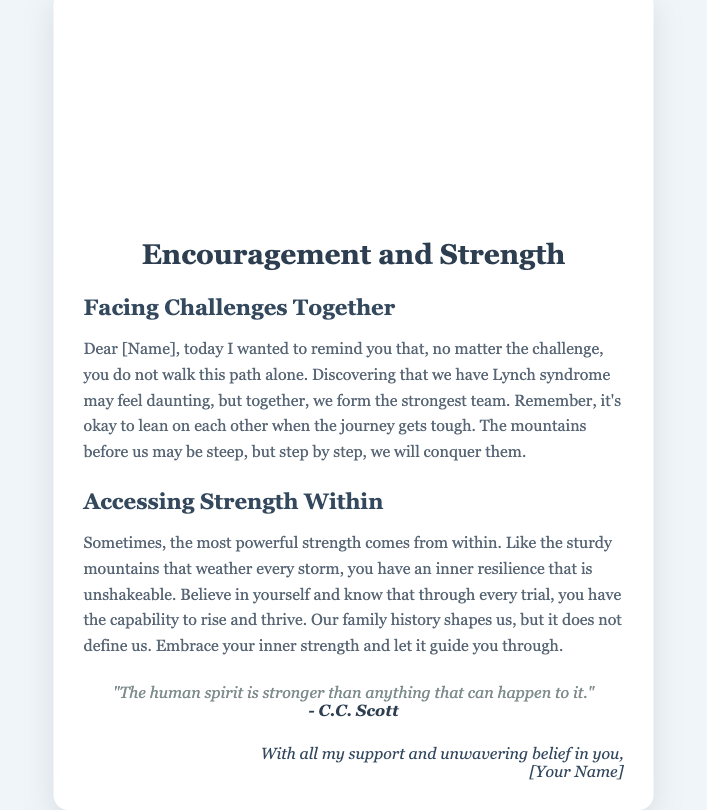What is the title of the card? The title is prominently displayed at the top of the card.
Answer: Encouragement and Strength Who is the quote attributed to? The author of the quote is mentioned at the end of the quote section.
Answer: C.C. Scott What is the main theme of the card? The card focuses on uplifting messages regarding overcoming challenges.
Answer: Encouragement and Strength What does the card encourage people to do together? The text specifically mentions what is advised to do when facing challenges.
Answer: Face challenges together What is one of the metaphors used in the card? A powerful metaphor is introduced to symbolize resilience throughout the content of the card.
Answer: Sturdy mountains What is the color of the text in the footer? The footer's text color is specified in the document styling.
Answer: #34495e What should one embrace according to the card? A key message in the content is about something that helps navigate through tough times.
Answer: Inner strength What does the card say about family history? The document provides insight on how family history relates to personal identity.
Answer: Shapes but does not define us 